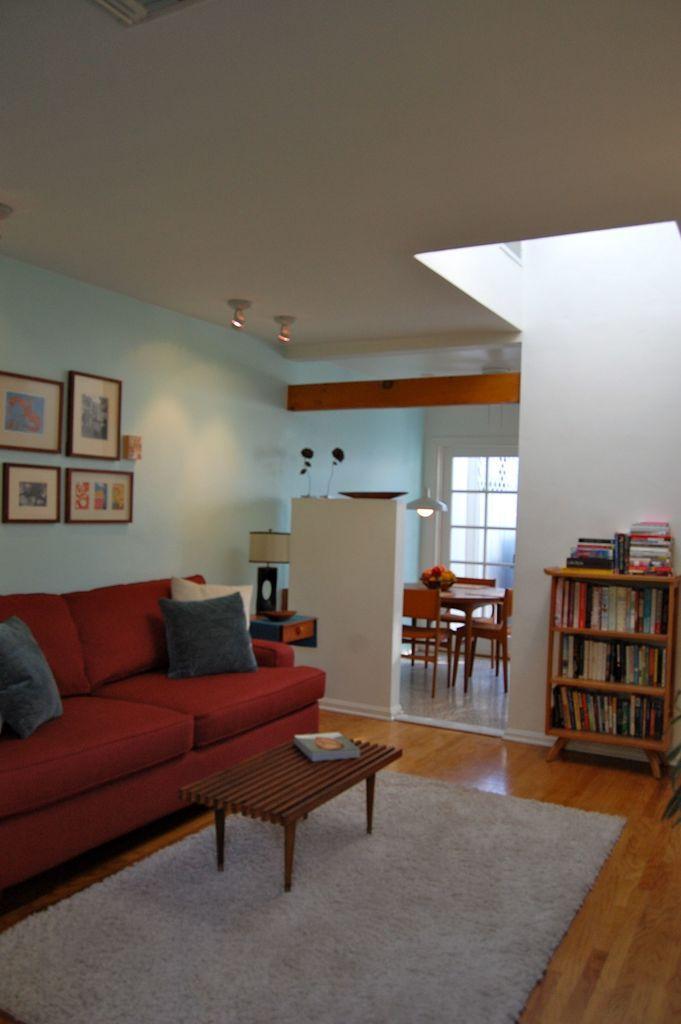In one or two sentences, can you explain what this image depicts? In the image we can see there is a hall in which there is sofa and on the wall there are photo frames. There is a small bookshelf in which books are there and on the table there is a book and on the floor there is a floor mat. 